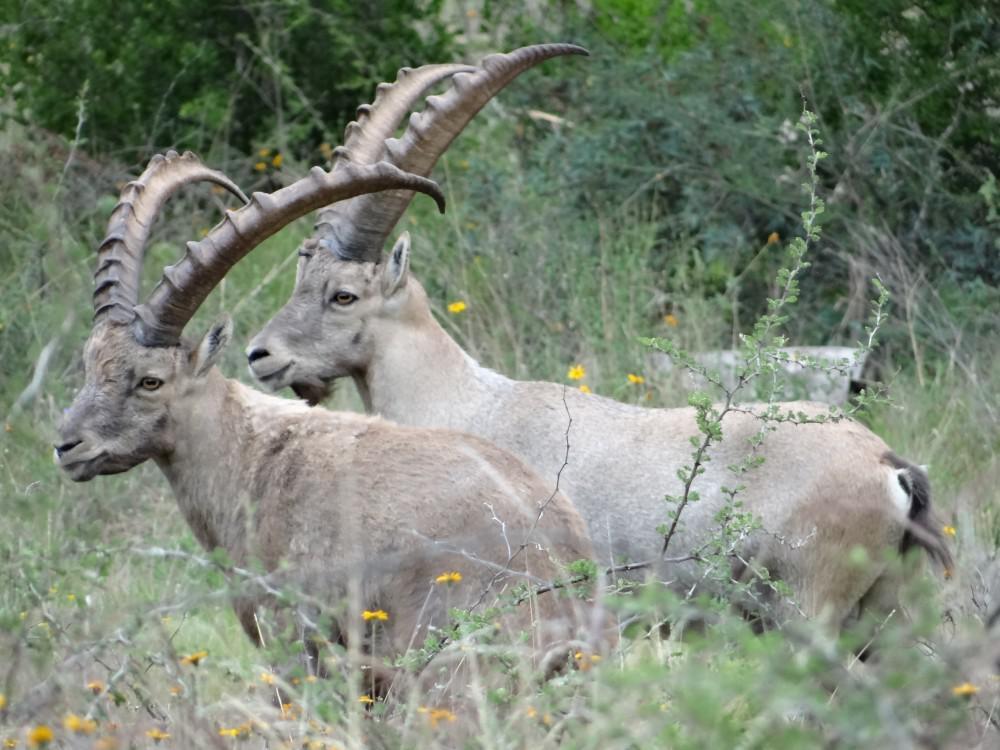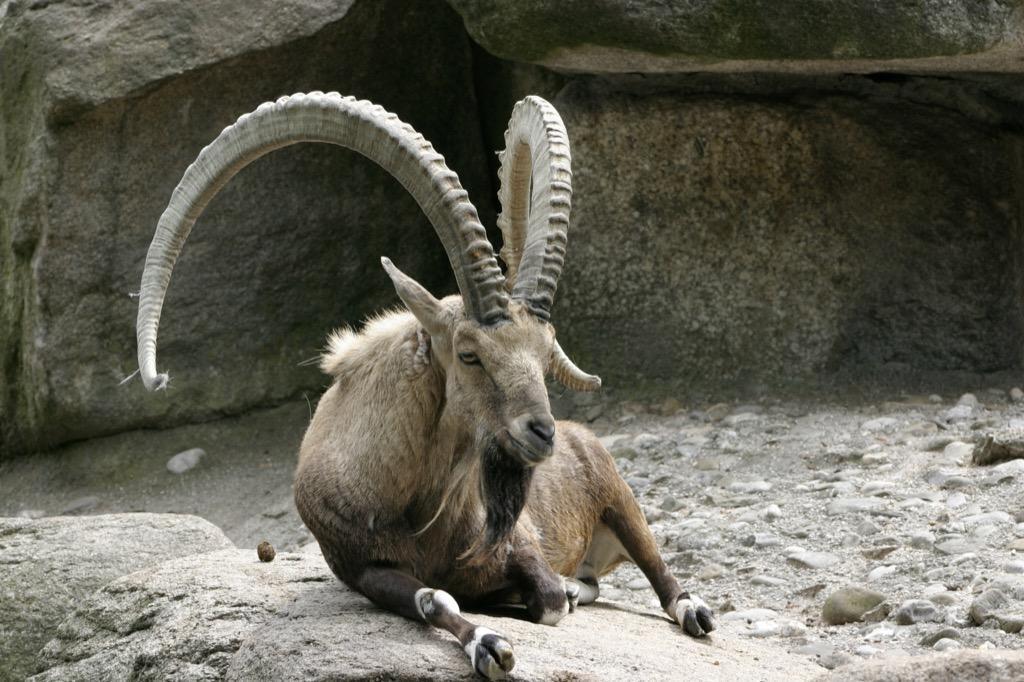The first image is the image on the left, the second image is the image on the right. Assess this claim about the two images: "The are two mountain goats on the left image.". Correct or not? Answer yes or no. Yes. The first image is the image on the left, the second image is the image on the right. Analyze the images presented: Is the assertion "A long horn sheep is laying on the ground" valid? Answer yes or no. Yes. 